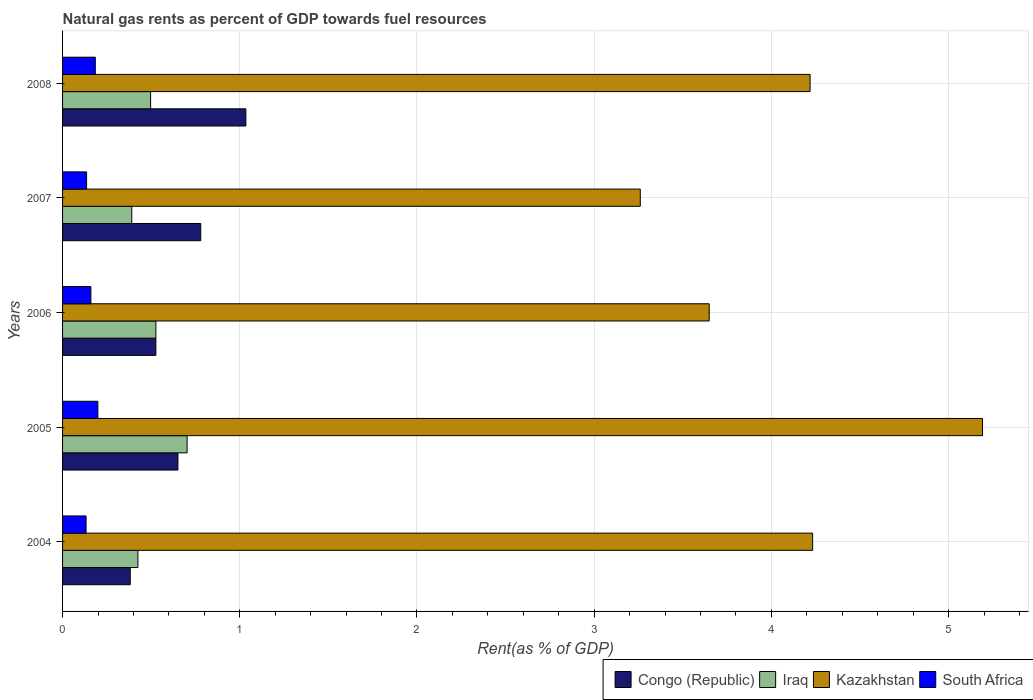How many groups of bars are there?
Offer a terse response. 5. Are the number of bars on each tick of the Y-axis equal?
Your answer should be very brief. Yes. How many bars are there on the 1st tick from the top?
Keep it short and to the point. 4. What is the label of the 2nd group of bars from the top?
Provide a succinct answer. 2007. What is the matural gas rent in Iraq in 2004?
Ensure brevity in your answer.  0.43. Across all years, what is the maximum matural gas rent in South Africa?
Your answer should be compact. 0.2. Across all years, what is the minimum matural gas rent in Kazakhstan?
Your answer should be very brief. 3.26. What is the total matural gas rent in Congo (Republic) in the graph?
Your answer should be compact. 3.37. What is the difference between the matural gas rent in South Africa in 2004 and that in 2005?
Your answer should be very brief. -0.07. What is the difference between the matural gas rent in Congo (Republic) in 2006 and the matural gas rent in Kazakhstan in 2008?
Your answer should be very brief. -3.69. What is the average matural gas rent in Congo (Republic) per year?
Provide a succinct answer. 0.67. In the year 2004, what is the difference between the matural gas rent in Kazakhstan and matural gas rent in Iraq?
Offer a terse response. 3.81. What is the ratio of the matural gas rent in Iraq in 2004 to that in 2005?
Offer a terse response. 0.61. Is the matural gas rent in Kazakhstan in 2005 less than that in 2007?
Offer a terse response. No. What is the difference between the highest and the second highest matural gas rent in South Africa?
Your answer should be very brief. 0.01. What is the difference between the highest and the lowest matural gas rent in Congo (Republic)?
Offer a very short reply. 0.65. What does the 4th bar from the top in 2007 represents?
Make the answer very short. Congo (Republic). What does the 2nd bar from the bottom in 2005 represents?
Keep it short and to the point. Iraq. Is it the case that in every year, the sum of the matural gas rent in South Africa and matural gas rent in Kazakhstan is greater than the matural gas rent in Congo (Republic)?
Your response must be concise. Yes. How many bars are there?
Provide a short and direct response. 20. What is the difference between two consecutive major ticks on the X-axis?
Your answer should be very brief. 1. Does the graph contain any zero values?
Give a very brief answer. No. Does the graph contain grids?
Offer a terse response. Yes. What is the title of the graph?
Your answer should be very brief. Natural gas rents as percent of GDP towards fuel resources. Does "Poland" appear as one of the legend labels in the graph?
Provide a short and direct response. No. What is the label or title of the X-axis?
Offer a terse response. Rent(as % of GDP). What is the label or title of the Y-axis?
Offer a very short reply. Years. What is the Rent(as % of GDP) in Congo (Republic) in 2004?
Offer a very short reply. 0.38. What is the Rent(as % of GDP) in Iraq in 2004?
Ensure brevity in your answer.  0.43. What is the Rent(as % of GDP) in Kazakhstan in 2004?
Offer a terse response. 4.23. What is the Rent(as % of GDP) of South Africa in 2004?
Offer a very short reply. 0.13. What is the Rent(as % of GDP) of Congo (Republic) in 2005?
Provide a succinct answer. 0.65. What is the Rent(as % of GDP) in Iraq in 2005?
Provide a succinct answer. 0.7. What is the Rent(as % of GDP) of Kazakhstan in 2005?
Provide a short and direct response. 5.19. What is the Rent(as % of GDP) of South Africa in 2005?
Your response must be concise. 0.2. What is the Rent(as % of GDP) of Congo (Republic) in 2006?
Give a very brief answer. 0.53. What is the Rent(as % of GDP) in Iraq in 2006?
Offer a very short reply. 0.53. What is the Rent(as % of GDP) in Kazakhstan in 2006?
Give a very brief answer. 3.65. What is the Rent(as % of GDP) of South Africa in 2006?
Provide a succinct answer. 0.16. What is the Rent(as % of GDP) of Congo (Republic) in 2007?
Provide a short and direct response. 0.78. What is the Rent(as % of GDP) in Iraq in 2007?
Provide a succinct answer. 0.39. What is the Rent(as % of GDP) of Kazakhstan in 2007?
Keep it short and to the point. 3.26. What is the Rent(as % of GDP) in South Africa in 2007?
Your answer should be very brief. 0.14. What is the Rent(as % of GDP) of Congo (Republic) in 2008?
Ensure brevity in your answer.  1.03. What is the Rent(as % of GDP) in Iraq in 2008?
Offer a terse response. 0.5. What is the Rent(as % of GDP) in Kazakhstan in 2008?
Your answer should be compact. 4.22. What is the Rent(as % of GDP) in South Africa in 2008?
Keep it short and to the point. 0.18. Across all years, what is the maximum Rent(as % of GDP) of Congo (Republic)?
Ensure brevity in your answer.  1.03. Across all years, what is the maximum Rent(as % of GDP) of Iraq?
Offer a terse response. 0.7. Across all years, what is the maximum Rent(as % of GDP) in Kazakhstan?
Make the answer very short. 5.19. Across all years, what is the maximum Rent(as % of GDP) in South Africa?
Your answer should be very brief. 0.2. Across all years, what is the minimum Rent(as % of GDP) in Congo (Republic)?
Offer a very short reply. 0.38. Across all years, what is the minimum Rent(as % of GDP) in Iraq?
Offer a terse response. 0.39. Across all years, what is the minimum Rent(as % of GDP) in Kazakhstan?
Your answer should be compact. 3.26. Across all years, what is the minimum Rent(as % of GDP) in South Africa?
Give a very brief answer. 0.13. What is the total Rent(as % of GDP) of Congo (Republic) in the graph?
Provide a short and direct response. 3.37. What is the total Rent(as % of GDP) of Iraq in the graph?
Provide a short and direct response. 2.54. What is the total Rent(as % of GDP) of Kazakhstan in the graph?
Make the answer very short. 20.55. What is the total Rent(as % of GDP) in South Africa in the graph?
Your answer should be very brief. 0.81. What is the difference between the Rent(as % of GDP) of Congo (Republic) in 2004 and that in 2005?
Your response must be concise. -0.27. What is the difference between the Rent(as % of GDP) of Iraq in 2004 and that in 2005?
Give a very brief answer. -0.28. What is the difference between the Rent(as % of GDP) in Kazakhstan in 2004 and that in 2005?
Keep it short and to the point. -0.96. What is the difference between the Rent(as % of GDP) in South Africa in 2004 and that in 2005?
Your answer should be very brief. -0.07. What is the difference between the Rent(as % of GDP) of Congo (Republic) in 2004 and that in 2006?
Ensure brevity in your answer.  -0.14. What is the difference between the Rent(as % of GDP) in Iraq in 2004 and that in 2006?
Ensure brevity in your answer.  -0.1. What is the difference between the Rent(as % of GDP) of Kazakhstan in 2004 and that in 2006?
Give a very brief answer. 0.58. What is the difference between the Rent(as % of GDP) in South Africa in 2004 and that in 2006?
Your answer should be very brief. -0.03. What is the difference between the Rent(as % of GDP) in Congo (Republic) in 2004 and that in 2007?
Your answer should be compact. -0.4. What is the difference between the Rent(as % of GDP) of Iraq in 2004 and that in 2007?
Your response must be concise. 0.03. What is the difference between the Rent(as % of GDP) of Kazakhstan in 2004 and that in 2007?
Offer a very short reply. 0.97. What is the difference between the Rent(as % of GDP) in South Africa in 2004 and that in 2007?
Your answer should be very brief. -0. What is the difference between the Rent(as % of GDP) in Congo (Republic) in 2004 and that in 2008?
Your answer should be compact. -0.65. What is the difference between the Rent(as % of GDP) in Iraq in 2004 and that in 2008?
Make the answer very short. -0.07. What is the difference between the Rent(as % of GDP) of Kazakhstan in 2004 and that in 2008?
Make the answer very short. 0.01. What is the difference between the Rent(as % of GDP) of South Africa in 2004 and that in 2008?
Keep it short and to the point. -0.05. What is the difference between the Rent(as % of GDP) of Congo (Republic) in 2005 and that in 2006?
Your answer should be very brief. 0.12. What is the difference between the Rent(as % of GDP) of Iraq in 2005 and that in 2006?
Your answer should be compact. 0.18. What is the difference between the Rent(as % of GDP) of Kazakhstan in 2005 and that in 2006?
Make the answer very short. 1.54. What is the difference between the Rent(as % of GDP) in South Africa in 2005 and that in 2006?
Give a very brief answer. 0.04. What is the difference between the Rent(as % of GDP) in Congo (Republic) in 2005 and that in 2007?
Your response must be concise. -0.13. What is the difference between the Rent(as % of GDP) in Iraq in 2005 and that in 2007?
Give a very brief answer. 0.31. What is the difference between the Rent(as % of GDP) in Kazakhstan in 2005 and that in 2007?
Keep it short and to the point. 1.93. What is the difference between the Rent(as % of GDP) in South Africa in 2005 and that in 2007?
Provide a succinct answer. 0.06. What is the difference between the Rent(as % of GDP) of Congo (Republic) in 2005 and that in 2008?
Offer a very short reply. -0.38. What is the difference between the Rent(as % of GDP) of Iraq in 2005 and that in 2008?
Your answer should be compact. 0.21. What is the difference between the Rent(as % of GDP) of Kazakhstan in 2005 and that in 2008?
Your response must be concise. 0.97. What is the difference between the Rent(as % of GDP) in South Africa in 2005 and that in 2008?
Provide a short and direct response. 0.01. What is the difference between the Rent(as % of GDP) of Congo (Republic) in 2006 and that in 2007?
Offer a terse response. -0.25. What is the difference between the Rent(as % of GDP) in Iraq in 2006 and that in 2007?
Offer a very short reply. 0.14. What is the difference between the Rent(as % of GDP) of Kazakhstan in 2006 and that in 2007?
Give a very brief answer. 0.39. What is the difference between the Rent(as % of GDP) in South Africa in 2006 and that in 2007?
Make the answer very short. 0.02. What is the difference between the Rent(as % of GDP) of Congo (Republic) in 2006 and that in 2008?
Your answer should be compact. -0.51. What is the difference between the Rent(as % of GDP) in Iraq in 2006 and that in 2008?
Ensure brevity in your answer.  0.03. What is the difference between the Rent(as % of GDP) in Kazakhstan in 2006 and that in 2008?
Provide a short and direct response. -0.57. What is the difference between the Rent(as % of GDP) in South Africa in 2006 and that in 2008?
Offer a terse response. -0.02. What is the difference between the Rent(as % of GDP) of Congo (Republic) in 2007 and that in 2008?
Your response must be concise. -0.25. What is the difference between the Rent(as % of GDP) of Iraq in 2007 and that in 2008?
Your answer should be very brief. -0.11. What is the difference between the Rent(as % of GDP) of Kazakhstan in 2007 and that in 2008?
Offer a very short reply. -0.96. What is the difference between the Rent(as % of GDP) in South Africa in 2007 and that in 2008?
Your answer should be compact. -0.05. What is the difference between the Rent(as % of GDP) in Congo (Republic) in 2004 and the Rent(as % of GDP) in Iraq in 2005?
Keep it short and to the point. -0.32. What is the difference between the Rent(as % of GDP) in Congo (Republic) in 2004 and the Rent(as % of GDP) in Kazakhstan in 2005?
Provide a short and direct response. -4.81. What is the difference between the Rent(as % of GDP) in Congo (Republic) in 2004 and the Rent(as % of GDP) in South Africa in 2005?
Keep it short and to the point. 0.18. What is the difference between the Rent(as % of GDP) in Iraq in 2004 and the Rent(as % of GDP) in Kazakhstan in 2005?
Keep it short and to the point. -4.77. What is the difference between the Rent(as % of GDP) in Iraq in 2004 and the Rent(as % of GDP) in South Africa in 2005?
Your response must be concise. 0.23. What is the difference between the Rent(as % of GDP) in Kazakhstan in 2004 and the Rent(as % of GDP) in South Africa in 2005?
Provide a short and direct response. 4.03. What is the difference between the Rent(as % of GDP) of Congo (Republic) in 2004 and the Rent(as % of GDP) of Iraq in 2006?
Give a very brief answer. -0.14. What is the difference between the Rent(as % of GDP) of Congo (Republic) in 2004 and the Rent(as % of GDP) of Kazakhstan in 2006?
Provide a succinct answer. -3.27. What is the difference between the Rent(as % of GDP) of Congo (Republic) in 2004 and the Rent(as % of GDP) of South Africa in 2006?
Offer a very short reply. 0.22. What is the difference between the Rent(as % of GDP) of Iraq in 2004 and the Rent(as % of GDP) of Kazakhstan in 2006?
Your answer should be compact. -3.22. What is the difference between the Rent(as % of GDP) of Iraq in 2004 and the Rent(as % of GDP) of South Africa in 2006?
Give a very brief answer. 0.27. What is the difference between the Rent(as % of GDP) in Kazakhstan in 2004 and the Rent(as % of GDP) in South Africa in 2006?
Your answer should be very brief. 4.07. What is the difference between the Rent(as % of GDP) in Congo (Republic) in 2004 and the Rent(as % of GDP) in Iraq in 2007?
Provide a succinct answer. -0.01. What is the difference between the Rent(as % of GDP) of Congo (Republic) in 2004 and the Rent(as % of GDP) of Kazakhstan in 2007?
Provide a short and direct response. -2.88. What is the difference between the Rent(as % of GDP) in Congo (Republic) in 2004 and the Rent(as % of GDP) in South Africa in 2007?
Provide a succinct answer. 0.25. What is the difference between the Rent(as % of GDP) in Iraq in 2004 and the Rent(as % of GDP) in Kazakhstan in 2007?
Ensure brevity in your answer.  -2.83. What is the difference between the Rent(as % of GDP) in Iraq in 2004 and the Rent(as % of GDP) in South Africa in 2007?
Provide a short and direct response. 0.29. What is the difference between the Rent(as % of GDP) of Kazakhstan in 2004 and the Rent(as % of GDP) of South Africa in 2007?
Your answer should be compact. 4.1. What is the difference between the Rent(as % of GDP) in Congo (Republic) in 2004 and the Rent(as % of GDP) in Iraq in 2008?
Offer a terse response. -0.11. What is the difference between the Rent(as % of GDP) in Congo (Republic) in 2004 and the Rent(as % of GDP) in Kazakhstan in 2008?
Make the answer very short. -3.84. What is the difference between the Rent(as % of GDP) of Congo (Republic) in 2004 and the Rent(as % of GDP) of South Africa in 2008?
Give a very brief answer. 0.2. What is the difference between the Rent(as % of GDP) in Iraq in 2004 and the Rent(as % of GDP) in Kazakhstan in 2008?
Provide a succinct answer. -3.79. What is the difference between the Rent(as % of GDP) in Iraq in 2004 and the Rent(as % of GDP) in South Africa in 2008?
Ensure brevity in your answer.  0.24. What is the difference between the Rent(as % of GDP) of Kazakhstan in 2004 and the Rent(as % of GDP) of South Africa in 2008?
Make the answer very short. 4.05. What is the difference between the Rent(as % of GDP) in Congo (Republic) in 2005 and the Rent(as % of GDP) in Iraq in 2006?
Offer a terse response. 0.12. What is the difference between the Rent(as % of GDP) of Congo (Republic) in 2005 and the Rent(as % of GDP) of Kazakhstan in 2006?
Offer a terse response. -3. What is the difference between the Rent(as % of GDP) of Congo (Republic) in 2005 and the Rent(as % of GDP) of South Africa in 2006?
Offer a terse response. 0.49. What is the difference between the Rent(as % of GDP) of Iraq in 2005 and the Rent(as % of GDP) of Kazakhstan in 2006?
Offer a terse response. -2.95. What is the difference between the Rent(as % of GDP) in Iraq in 2005 and the Rent(as % of GDP) in South Africa in 2006?
Give a very brief answer. 0.54. What is the difference between the Rent(as % of GDP) of Kazakhstan in 2005 and the Rent(as % of GDP) of South Africa in 2006?
Your answer should be compact. 5.03. What is the difference between the Rent(as % of GDP) in Congo (Republic) in 2005 and the Rent(as % of GDP) in Iraq in 2007?
Keep it short and to the point. 0.26. What is the difference between the Rent(as % of GDP) of Congo (Republic) in 2005 and the Rent(as % of GDP) of Kazakhstan in 2007?
Your answer should be compact. -2.61. What is the difference between the Rent(as % of GDP) of Congo (Republic) in 2005 and the Rent(as % of GDP) of South Africa in 2007?
Give a very brief answer. 0.52. What is the difference between the Rent(as % of GDP) of Iraq in 2005 and the Rent(as % of GDP) of Kazakhstan in 2007?
Offer a very short reply. -2.56. What is the difference between the Rent(as % of GDP) in Iraq in 2005 and the Rent(as % of GDP) in South Africa in 2007?
Keep it short and to the point. 0.57. What is the difference between the Rent(as % of GDP) of Kazakhstan in 2005 and the Rent(as % of GDP) of South Africa in 2007?
Offer a terse response. 5.06. What is the difference between the Rent(as % of GDP) in Congo (Republic) in 2005 and the Rent(as % of GDP) in Iraq in 2008?
Offer a terse response. 0.15. What is the difference between the Rent(as % of GDP) in Congo (Republic) in 2005 and the Rent(as % of GDP) in Kazakhstan in 2008?
Give a very brief answer. -3.57. What is the difference between the Rent(as % of GDP) in Congo (Republic) in 2005 and the Rent(as % of GDP) in South Africa in 2008?
Offer a very short reply. 0.47. What is the difference between the Rent(as % of GDP) of Iraq in 2005 and the Rent(as % of GDP) of Kazakhstan in 2008?
Give a very brief answer. -3.52. What is the difference between the Rent(as % of GDP) in Iraq in 2005 and the Rent(as % of GDP) in South Africa in 2008?
Ensure brevity in your answer.  0.52. What is the difference between the Rent(as % of GDP) of Kazakhstan in 2005 and the Rent(as % of GDP) of South Africa in 2008?
Your answer should be compact. 5.01. What is the difference between the Rent(as % of GDP) of Congo (Republic) in 2006 and the Rent(as % of GDP) of Iraq in 2007?
Ensure brevity in your answer.  0.14. What is the difference between the Rent(as % of GDP) of Congo (Republic) in 2006 and the Rent(as % of GDP) of Kazakhstan in 2007?
Provide a short and direct response. -2.73. What is the difference between the Rent(as % of GDP) in Congo (Republic) in 2006 and the Rent(as % of GDP) in South Africa in 2007?
Keep it short and to the point. 0.39. What is the difference between the Rent(as % of GDP) of Iraq in 2006 and the Rent(as % of GDP) of Kazakhstan in 2007?
Provide a short and direct response. -2.73. What is the difference between the Rent(as % of GDP) of Iraq in 2006 and the Rent(as % of GDP) of South Africa in 2007?
Make the answer very short. 0.39. What is the difference between the Rent(as % of GDP) in Kazakhstan in 2006 and the Rent(as % of GDP) in South Africa in 2007?
Keep it short and to the point. 3.51. What is the difference between the Rent(as % of GDP) of Congo (Republic) in 2006 and the Rent(as % of GDP) of Iraq in 2008?
Provide a short and direct response. 0.03. What is the difference between the Rent(as % of GDP) in Congo (Republic) in 2006 and the Rent(as % of GDP) in Kazakhstan in 2008?
Your response must be concise. -3.69. What is the difference between the Rent(as % of GDP) in Congo (Republic) in 2006 and the Rent(as % of GDP) in South Africa in 2008?
Give a very brief answer. 0.34. What is the difference between the Rent(as % of GDP) of Iraq in 2006 and the Rent(as % of GDP) of Kazakhstan in 2008?
Make the answer very short. -3.69. What is the difference between the Rent(as % of GDP) in Iraq in 2006 and the Rent(as % of GDP) in South Africa in 2008?
Your response must be concise. 0.34. What is the difference between the Rent(as % of GDP) of Kazakhstan in 2006 and the Rent(as % of GDP) of South Africa in 2008?
Your response must be concise. 3.46. What is the difference between the Rent(as % of GDP) of Congo (Republic) in 2007 and the Rent(as % of GDP) of Iraq in 2008?
Provide a succinct answer. 0.28. What is the difference between the Rent(as % of GDP) in Congo (Republic) in 2007 and the Rent(as % of GDP) in Kazakhstan in 2008?
Your answer should be very brief. -3.44. What is the difference between the Rent(as % of GDP) of Congo (Republic) in 2007 and the Rent(as % of GDP) of South Africa in 2008?
Offer a terse response. 0.6. What is the difference between the Rent(as % of GDP) of Iraq in 2007 and the Rent(as % of GDP) of Kazakhstan in 2008?
Your response must be concise. -3.83. What is the difference between the Rent(as % of GDP) in Iraq in 2007 and the Rent(as % of GDP) in South Africa in 2008?
Offer a very short reply. 0.21. What is the difference between the Rent(as % of GDP) of Kazakhstan in 2007 and the Rent(as % of GDP) of South Africa in 2008?
Keep it short and to the point. 3.08. What is the average Rent(as % of GDP) of Congo (Republic) per year?
Your answer should be compact. 0.67. What is the average Rent(as % of GDP) in Iraq per year?
Keep it short and to the point. 0.51. What is the average Rent(as % of GDP) in Kazakhstan per year?
Your answer should be compact. 4.11. What is the average Rent(as % of GDP) in South Africa per year?
Keep it short and to the point. 0.16. In the year 2004, what is the difference between the Rent(as % of GDP) in Congo (Republic) and Rent(as % of GDP) in Iraq?
Your answer should be compact. -0.04. In the year 2004, what is the difference between the Rent(as % of GDP) in Congo (Republic) and Rent(as % of GDP) in Kazakhstan?
Your answer should be compact. -3.85. In the year 2004, what is the difference between the Rent(as % of GDP) in Congo (Republic) and Rent(as % of GDP) in South Africa?
Keep it short and to the point. 0.25. In the year 2004, what is the difference between the Rent(as % of GDP) in Iraq and Rent(as % of GDP) in Kazakhstan?
Keep it short and to the point. -3.81. In the year 2004, what is the difference between the Rent(as % of GDP) of Iraq and Rent(as % of GDP) of South Africa?
Keep it short and to the point. 0.29. In the year 2004, what is the difference between the Rent(as % of GDP) in Kazakhstan and Rent(as % of GDP) in South Africa?
Give a very brief answer. 4.1. In the year 2005, what is the difference between the Rent(as % of GDP) in Congo (Republic) and Rent(as % of GDP) in Iraq?
Offer a very short reply. -0.05. In the year 2005, what is the difference between the Rent(as % of GDP) in Congo (Republic) and Rent(as % of GDP) in Kazakhstan?
Give a very brief answer. -4.54. In the year 2005, what is the difference between the Rent(as % of GDP) of Congo (Republic) and Rent(as % of GDP) of South Africa?
Your answer should be compact. 0.45. In the year 2005, what is the difference between the Rent(as % of GDP) in Iraq and Rent(as % of GDP) in Kazakhstan?
Your answer should be compact. -4.49. In the year 2005, what is the difference between the Rent(as % of GDP) of Iraq and Rent(as % of GDP) of South Africa?
Offer a very short reply. 0.5. In the year 2005, what is the difference between the Rent(as % of GDP) of Kazakhstan and Rent(as % of GDP) of South Africa?
Give a very brief answer. 4.99. In the year 2006, what is the difference between the Rent(as % of GDP) of Congo (Republic) and Rent(as % of GDP) of Kazakhstan?
Provide a succinct answer. -3.12. In the year 2006, what is the difference between the Rent(as % of GDP) in Congo (Republic) and Rent(as % of GDP) in South Africa?
Offer a terse response. 0.37. In the year 2006, what is the difference between the Rent(as % of GDP) of Iraq and Rent(as % of GDP) of Kazakhstan?
Your response must be concise. -3.12. In the year 2006, what is the difference between the Rent(as % of GDP) in Iraq and Rent(as % of GDP) in South Africa?
Ensure brevity in your answer.  0.37. In the year 2006, what is the difference between the Rent(as % of GDP) of Kazakhstan and Rent(as % of GDP) of South Africa?
Ensure brevity in your answer.  3.49. In the year 2007, what is the difference between the Rent(as % of GDP) of Congo (Republic) and Rent(as % of GDP) of Iraq?
Provide a succinct answer. 0.39. In the year 2007, what is the difference between the Rent(as % of GDP) in Congo (Republic) and Rent(as % of GDP) in Kazakhstan?
Make the answer very short. -2.48. In the year 2007, what is the difference between the Rent(as % of GDP) in Congo (Republic) and Rent(as % of GDP) in South Africa?
Your answer should be compact. 0.64. In the year 2007, what is the difference between the Rent(as % of GDP) in Iraq and Rent(as % of GDP) in Kazakhstan?
Your answer should be compact. -2.87. In the year 2007, what is the difference between the Rent(as % of GDP) of Iraq and Rent(as % of GDP) of South Africa?
Give a very brief answer. 0.26. In the year 2007, what is the difference between the Rent(as % of GDP) of Kazakhstan and Rent(as % of GDP) of South Africa?
Keep it short and to the point. 3.12. In the year 2008, what is the difference between the Rent(as % of GDP) in Congo (Republic) and Rent(as % of GDP) in Iraq?
Offer a terse response. 0.54. In the year 2008, what is the difference between the Rent(as % of GDP) in Congo (Republic) and Rent(as % of GDP) in Kazakhstan?
Provide a succinct answer. -3.18. In the year 2008, what is the difference between the Rent(as % of GDP) of Congo (Republic) and Rent(as % of GDP) of South Africa?
Make the answer very short. 0.85. In the year 2008, what is the difference between the Rent(as % of GDP) in Iraq and Rent(as % of GDP) in Kazakhstan?
Your answer should be very brief. -3.72. In the year 2008, what is the difference between the Rent(as % of GDP) in Iraq and Rent(as % of GDP) in South Africa?
Keep it short and to the point. 0.31. In the year 2008, what is the difference between the Rent(as % of GDP) in Kazakhstan and Rent(as % of GDP) in South Africa?
Keep it short and to the point. 4.03. What is the ratio of the Rent(as % of GDP) in Congo (Republic) in 2004 to that in 2005?
Your answer should be compact. 0.59. What is the ratio of the Rent(as % of GDP) of Iraq in 2004 to that in 2005?
Give a very brief answer. 0.61. What is the ratio of the Rent(as % of GDP) in Kazakhstan in 2004 to that in 2005?
Offer a very short reply. 0.82. What is the ratio of the Rent(as % of GDP) of South Africa in 2004 to that in 2005?
Keep it short and to the point. 0.67. What is the ratio of the Rent(as % of GDP) of Congo (Republic) in 2004 to that in 2006?
Your response must be concise. 0.73. What is the ratio of the Rent(as % of GDP) in Iraq in 2004 to that in 2006?
Ensure brevity in your answer.  0.81. What is the ratio of the Rent(as % of GDP) in Kazakhstan in 2004 to that in 2006?
Your answer should be very brief. 1.16. What is the ratio of the Rent(as % of GDP) of South Africa in 2004 to that in 2006?
Give a very brief answer. 0.83. What is the ratio of the Rent(as % of GDP) of Congo (Republic) in 2004 to that in 2007?
Your response must be concise. 0.49. What is the ratio of the Rent(as % of GDP) in Iraq in 2004 to that in 2007?
Provide a short and direct response. 1.09. What is the ratio of the Rent(as % of GDP) in Kazakhstan in 2004 to that in 2007?
Provide a succinct answer. 1.3. What is the ratio of the Rent(as % of GDP) in South Africa in 2004 to that in 2007?
Your answer should be very brief. 0.98. What is the ratio of the Rent(as % of GDP) of Congo (Republic) in 2004 to that in 2008?
Ensure brevity in your answer.  0.37. What is the ratio of the Rent(as % of GDP) in Iraq in 2004 to that in 2008?
Provide a succinct answer. 0.86. What is the ratio of the Rent(as % of GDP) in Kazakhstan in 2004 to that in 2008?
Your response must be concise. 1. What is the ratio of the Rent(as % of GDP) of South Africa in 2004 to that in 2008?
Ensure brevity in your answer.  0.72. What is the ratio of the Rent(as % of GDP) of Congo (Republic) in 2005 to that in 2006?
Your response must be concise. 1.24. What is the ratio of the Rent(as % of GDP) of Iraq in 2005 to that in 2006?
Keep it short and to the point. 1.33. What is the ratio of the Rent(as % of GDP) in Kazakhstan in 2005 to that in 2006?
Your response must be concise. 1.42. What is the ratio of the Rent(as % of GDP) of South Africa in 2005 to that in 2006?
Provide a succinct answer. 1.25. What is the ratio of the Rent(as % of GDP) in Congo (Republic) in 2005 to that in 2007?
Give a very brief answer. 0.83. What is the ratio of the Rent(as % of GDP) of Iraq in 2005 to that in 2007?
Your answer should be very brief. 1.8. What is the ratio of the Rent(as % of GDP) of Kazakhstan in 2005 to that in 2007?
Provide a short and direct response. 1.59. What is the ratio of the Rent(as % of GDP) in South Africa in 2005 to that in 2007?
Offer a terse response. 1.47. What is the ratio of the Rent(as % of GDP) in Congo (Republic) in 2005 to that in 2008?
Provide a short and direct response. 0.63. What is the ratio of the Rent(as % of GDP) in Iraq in 2005 to that in 2008?
Keep it short and to the point. 1.41. What is the ratio of the Rent(as % of GDP) in Kazakhstan in 2005 to that in 2008?
Give a very brief answer. 1.23. What is the ratio of the Rent(as % of GDP) of South Africa in 2005 to that in 2008?
Provide a short and direct response. 1.08. What is the ratio of the Rent(as % of GDP) in Congo (Republic) in 2006 to that in 2007?
Ensure brevity in your answer.  0.68. What is the ratio of the Rent(as % of GDP) of Iraq in 2006 to that in 2007?
Your answer should be compact. 1.35. What is the ratio of the Rent(as % of GDP) of Kazakhstan in 2006 to that in 2007?
Offer a very short reply. 1.12. What is the ratio of the Rent(as % of GDP) of South Africa in 2006 to that in 2007?
Offer a very short reply. 1.18. What is the ratio of the Rent(as % of GDP) in Congo (Republic) in 2006 to that in 2008?
Offer a very short reply. 0.51. What is the ratio of the Rent(as % of GDP) of Iraq in 2006 to that in 2008?
Make the answer very short. 1.06. What is the ratio of the Rent(as % of GDP) of Kazakhstan in 2006 to that in 2008?
Your answer should be very brief. 0.87. What is the ratio of the Rent(as % of GDP) of South Africa in 2006 to that in 2008?
Make the answer very short. 0.86. What is the ratio of the Rent(as % of GDP) in Congo (Republic) in 2007 to that in 2008?
Ensure brevity in your answer.  0.75. What is the ratio of the Rent(as % of GDP) in Iraq in 2007 to that in 2008?
Give a very brief answer. 0.79. What is the ratio of the Rent(as % of GDP) of Kazakhstan in 2007 to that in 2008?
Make the answer very short. 0.77. What is the ratio of the Rent(as % of GDP) of South Africa in 2007 to that in 2008?
Provide a succinct answer. 0.73. What is the difference between the highest and the second highest Rent(as % of GDP) of Congo (Republic)?
Your answer should be compact. 0.25. What is the difference between the highest and the second highest Rent(as % of GDP) in Iraq?
Ensure brevity in your answer.  0.18. What is the difference between the highest and the second highest Rent(as % of GDP) in Kazakhstan?
Provide a short and direct response. 0.96. What is the difference between the highest and the second highest Rent(as % of GDP) in South Africa?
Make the answer very short. 0.01. What is the difference between the highest and the lowest Rent(as % of GDP) in Congo (Republic)?
Provide a short and direct response. 0.65. What is the difference between the highest and the lowest Rent(as % of GDP) of Iraq?
Offer a very short reply. 0.31. What is the difference between the highest and the lowest Rent(as % of GDP) of Kazakhstan?
Offer a very short reply. 1.93. What is the difference between the highest and the lowest Rent(as % of GDP) of South Africa?
Make the answer very short. 0.07. 